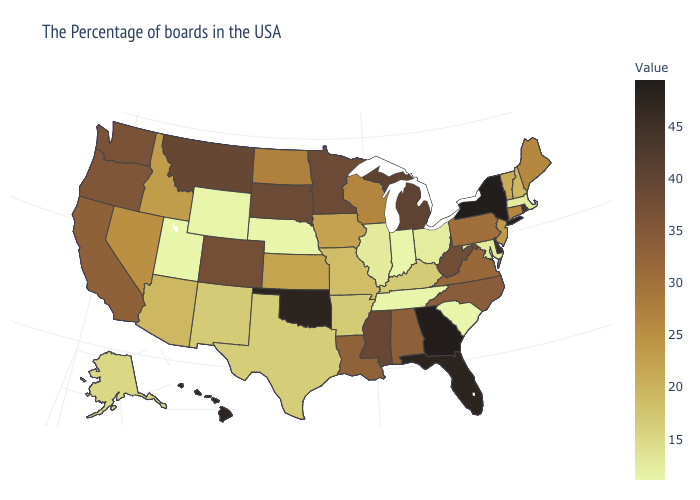Among the states that border South Carolina , which have the highest value?
Quick response, please. Georgia. Which states have the lowest value in the South?
Concise answer only. South Carolina, Tennessee. Among the states that border Maine , which have the lowest value?
Be succinct. New Hampshire. Does Georgia have the highest value in the South?
Write a very short answer. Yes. Does Washington have the lowest value in the USA?
Give a very brief answer. No. Among the states that border South Dakota , does Nebraska have the lowest value?
Keep it brief. Yes. 